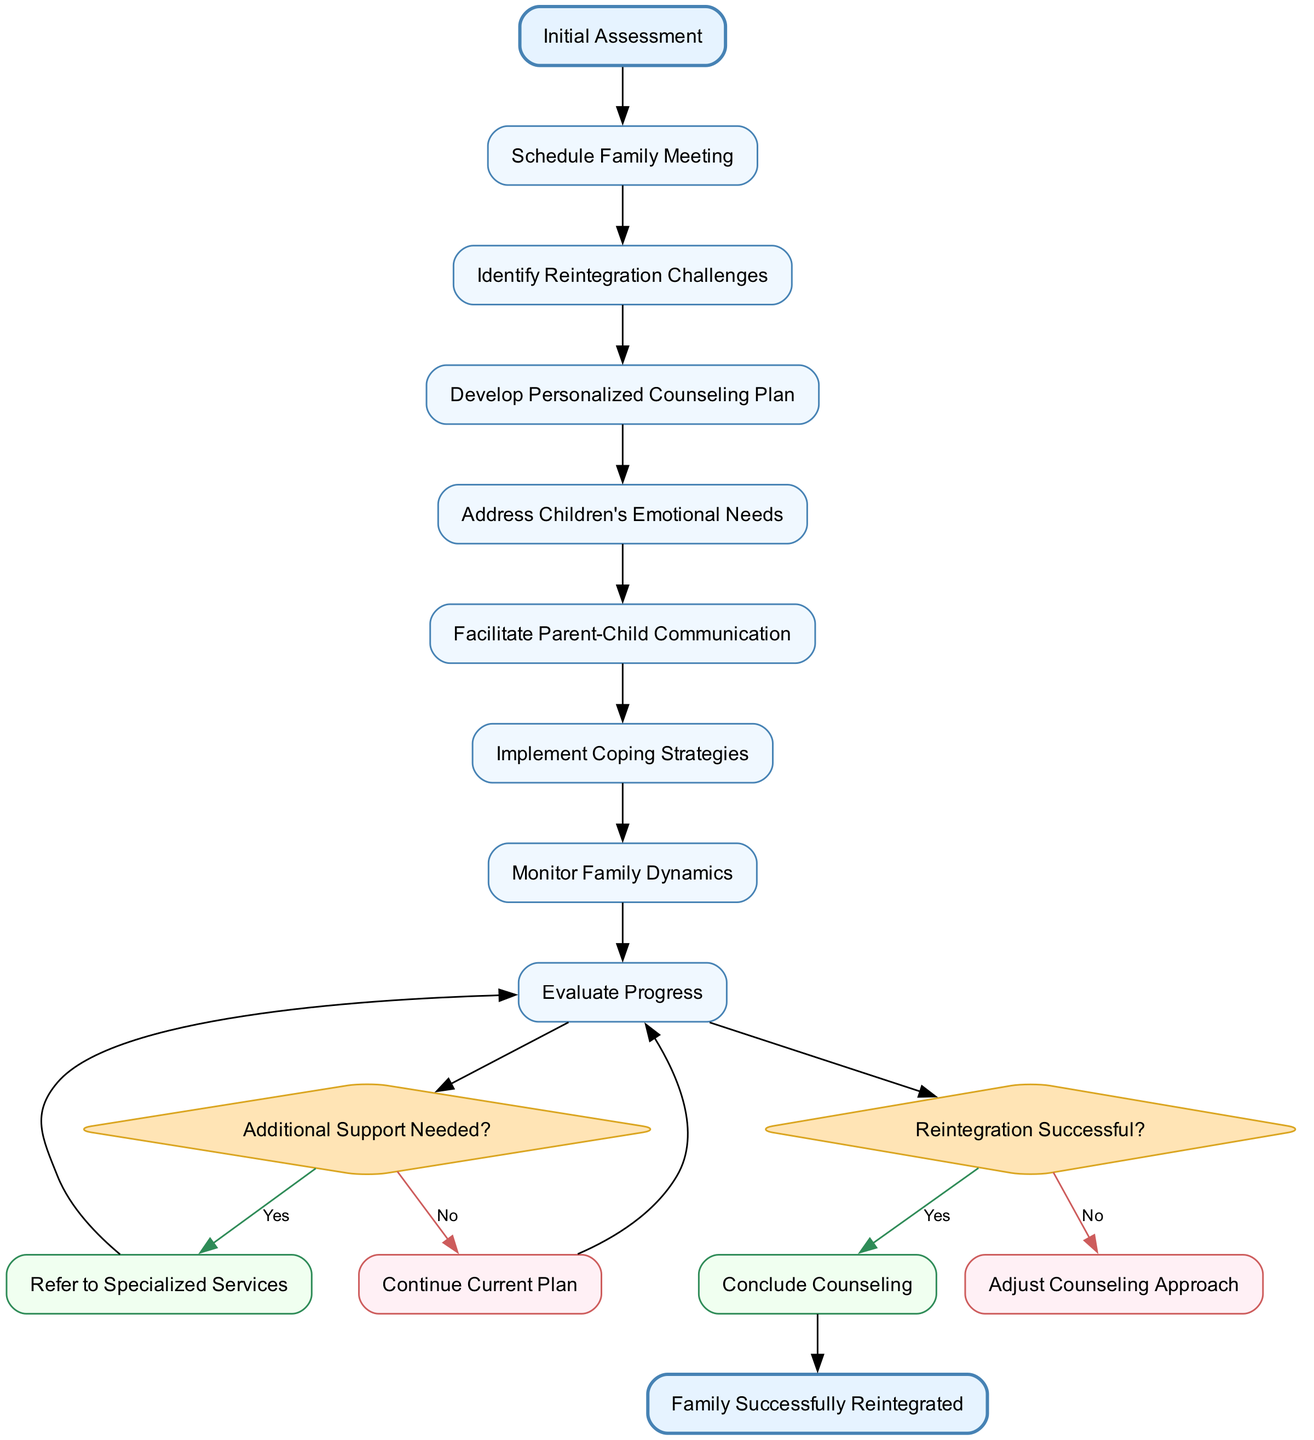What is the first activity in the diagram? The diagram starts with the "Initial Assessment" node, which serves as the beginning point for the activities listed.
Answer: Initial Assessment How many activities are there in total? The diagram contains eight activities that military families go through during the reintegration counseling process.
Answer: 8 What is the last stage before concluding counseling? The last decision point before concluding counseling is "Reintegration Successful?" indicating the effectiveness of the intervention.
Answer: Reintegration Successful? What happens if additional support is needed? If the condition "Additional Support Needed?" is assessed as "Yes," the next step is to "Refer to Specialized Services," which means seeking more focused help.
Answer: Refer to Specialized Services What color represents the decision nodes in the diagram? The decision nodes are represented in a diamond shape with fill color "#FFE4B5," indicating their role in making key decisions in the counseling process.
Answer: #FFE4B5 In what activity do the children's emotional needs get addressed? The activity specifically focused on addressing the children's emotional needs is "Address Children's Emotional Needs," which is part of the counseling process flow.
Answer: Address Children's Emotional Needs What does the diagram show if reintegration is not successful? If "Reintegration Successful?" is assessed as "No," the next step in the diagram is to "Adjust Counseling Approach," indicating a need for reassessment.
Answer: Adjust Counseling Approach How many decision nodes are present in the diagram? There are two decision nodes in the diagram, each evaluating different conditions related to support and reintegration success.
Answer: 2 What is the endpoint of the diagram called? The endpoint of the diagram, which signifies the successful completion of the counseling process, is named "Family Successfully Reintegrated."
Answer: Family Successfully Reintegrated 